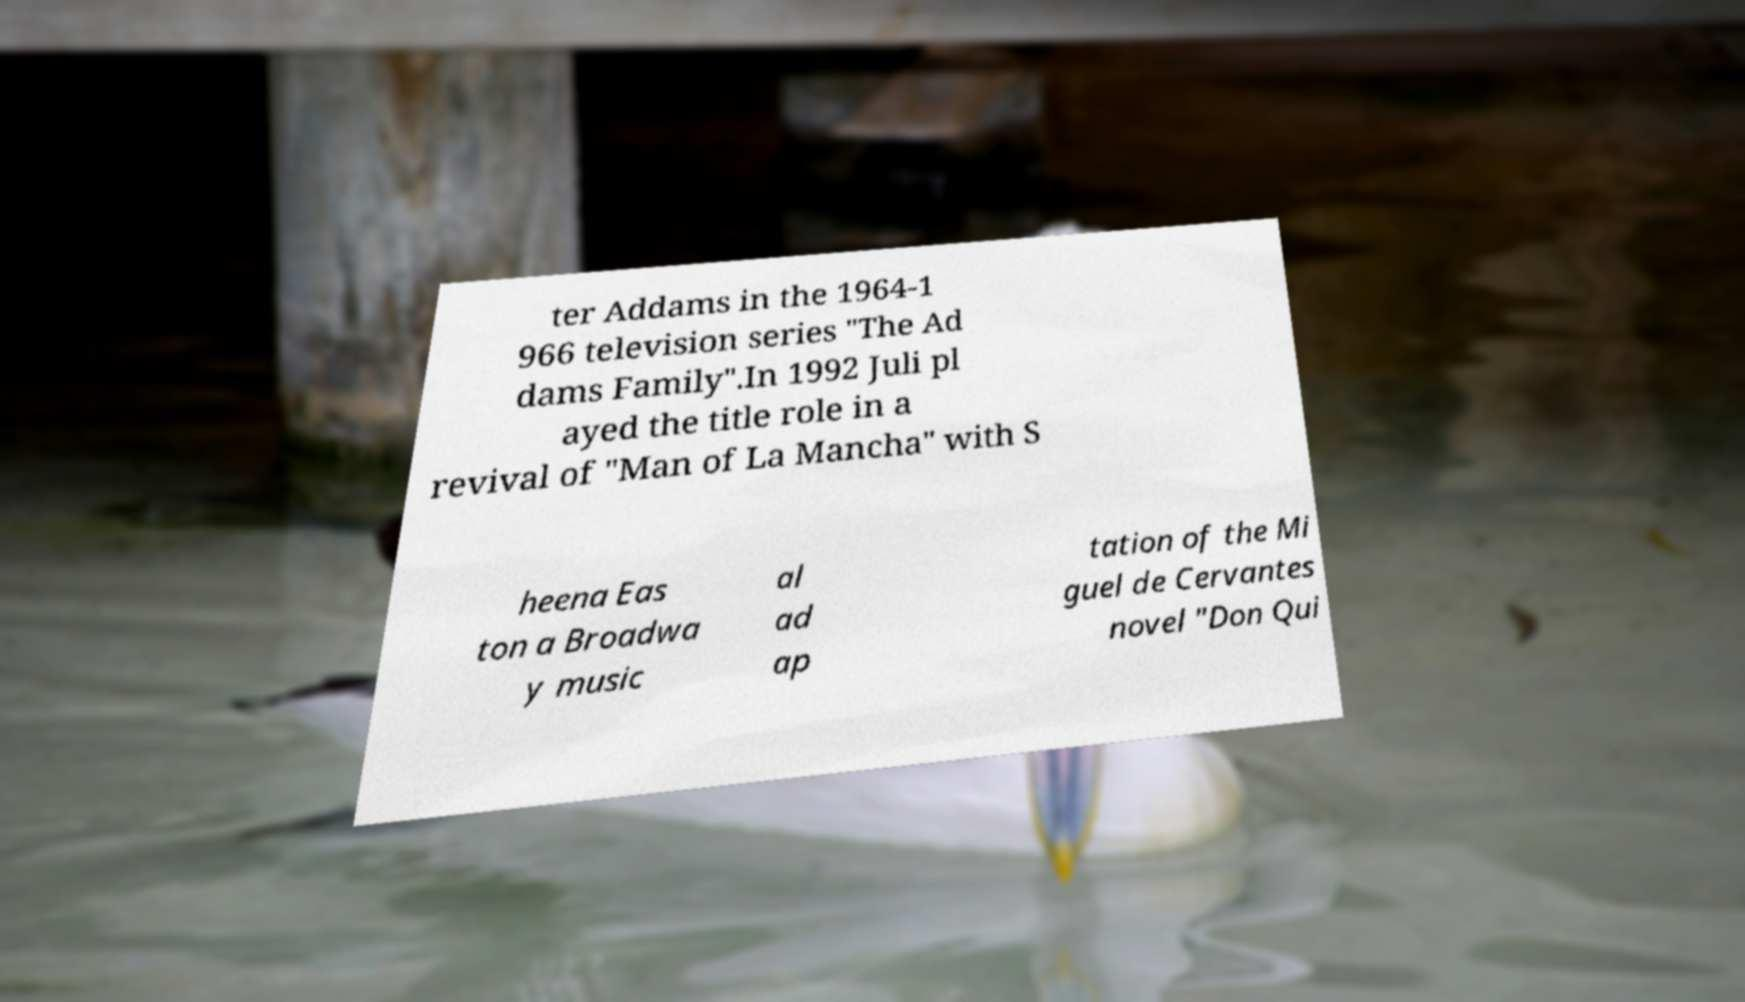Can you read and provide the text displayed in the image?This photo seems to have some interesting text. Can you extract and type it out for me? ter Addams in the 1964-1 966 television series "The Ad dams Family".In 1992 Juli pl ayed the title role in a revival of "Man of La Mancha" with S heena Eas ton a Broadwa y music al ad ap tation of the Mi guel de Cervantes novel "Don Qui 